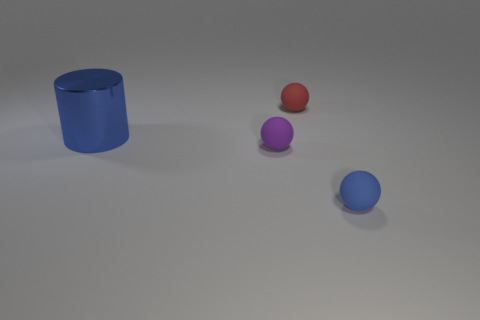There is a thing that is on the right side of the tiny purple matte sphere and left of the blue ball; what is it made of?
Your answer should be compact. Rubber. What shape is the small blue object that is the same material as the tiny red object?
Provide a short and direct response. Sphere. There is a rubber sphere that is to the left of the red rubber sphere; what number of objects are in front of it?
Provide a short and direct response. 1. What number of blue objects are both to the left of the small red matte object and on the right side of the tiny red thing?
Make the answer very short. 0. What number of other objects are there of the same material as the cylinder?
Your response must be concise. 0. What color is the matte object behind the matte thing that is left of the red rubber object?
Give a very brief answer. Red. Does the matte ball that is in front of the tiny purple rubber sphere have the same color as the metal object?
Keep it short and to the point. Yes. Is the purple ball the same size as the blue matte thing?
Make the answer very short. Yes. There is a red thing that is the same size as the blue rubber thing; what is its shape?
Ensure brevity in your answer.  Sphere. There is a blue thing behind the blue matte ball; is its size the same as the tiny blue object?
Your answer should be very brief. No. 